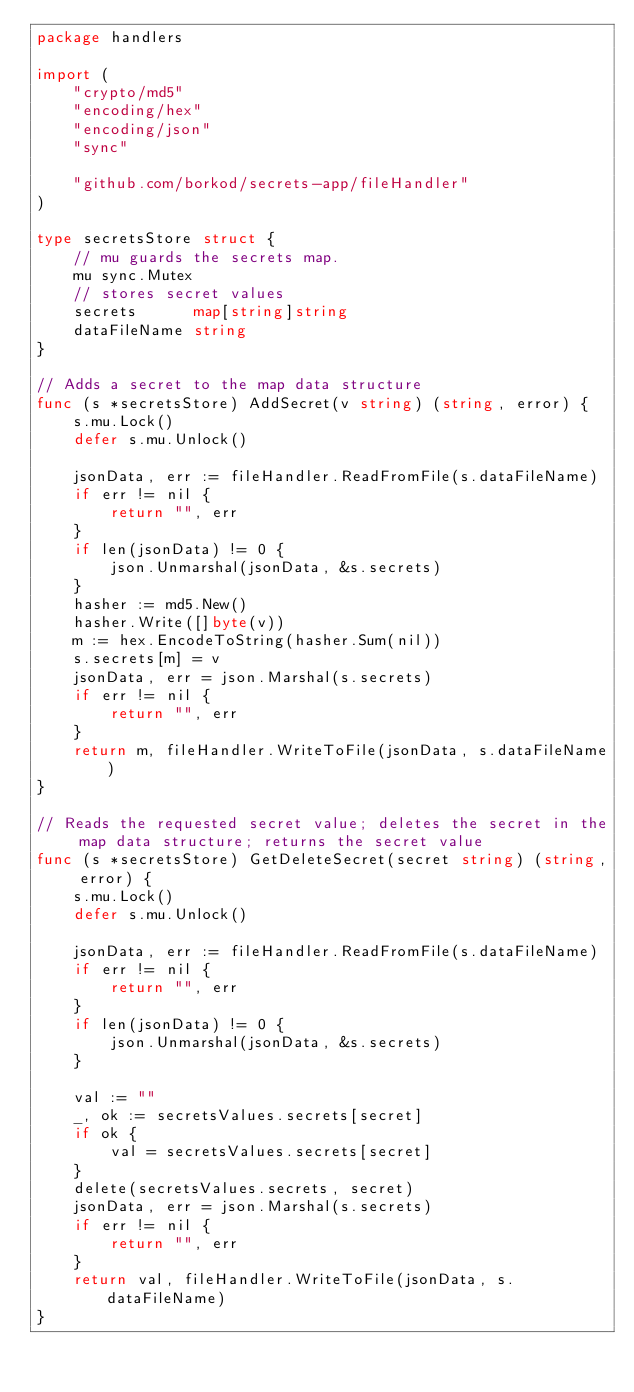<code> <loc_0><loc_0><loc_500><loc_500><_Go_>package handlers

import (
	"crypto/md5"
	"encoding/hex"
	"encoding/json"
	"sync"

	"github.com/borkod/secrets-app/fileHandler"
)

type secretsStore struct {
	// mu guards the secrets map.
	mu sync.Mutex
	// stores secret values
	secrets      map[string]string
	dataFileName string
}

// Adds a secret to the map data structure
func (s *secretsStore) AddSecret(v string) (string, error) {
	s.mu.Lock()
	defer s.mu.Unlock()

	jsonData, err := fileHandler.ReadFromFile(s.dataFileName)
	if err != nil {
		return "", err
	}
	if len(jsonData) != 0 {
		json.Unmarshal(jsonData, &s.secrets)
	}
	hasher := md5.New()
	hasher.Write([]byte(v))
	m := hex.EncodeToString(hasher.Sum(nil))
	s.secrets[m] = v
	jsonData, err = json.Marshal(s.secrets)
	if err != nil {
		return "", err
	}
	return m, fileHandler.WriteToFile(jsonData, s.dataFileName)
}

// Reads the requested secret value; deletes the secret in the map data structure; returns the secret value
func (s *secretsStore) GetDeleteSecret(secret string) (string, error) {
	s.mu.Lock()
	defer s.mu.Unlock()

	jsonData, err := fileHandler.ReadFromFile(s.dataFileName)
	if err != nil {
		return "", err
	}
	if len(jsonData) != 0 {
		json.Unmarshal(jsonData, &s.secrets)
	}

	val := ""
	_, ok := secretsValues.secrets[secret]
	if ok {
		val = secretsValues.secrets[secret]
	}
	delete(secretsValues.secrets, secret)
	jsonData, err = json.Marshal(s.secrets)
	if err != nil {
		return "", err
	}
	return val, fileHandler.WriteToFile(jsonData, s.dataFileName)
}
</code> 